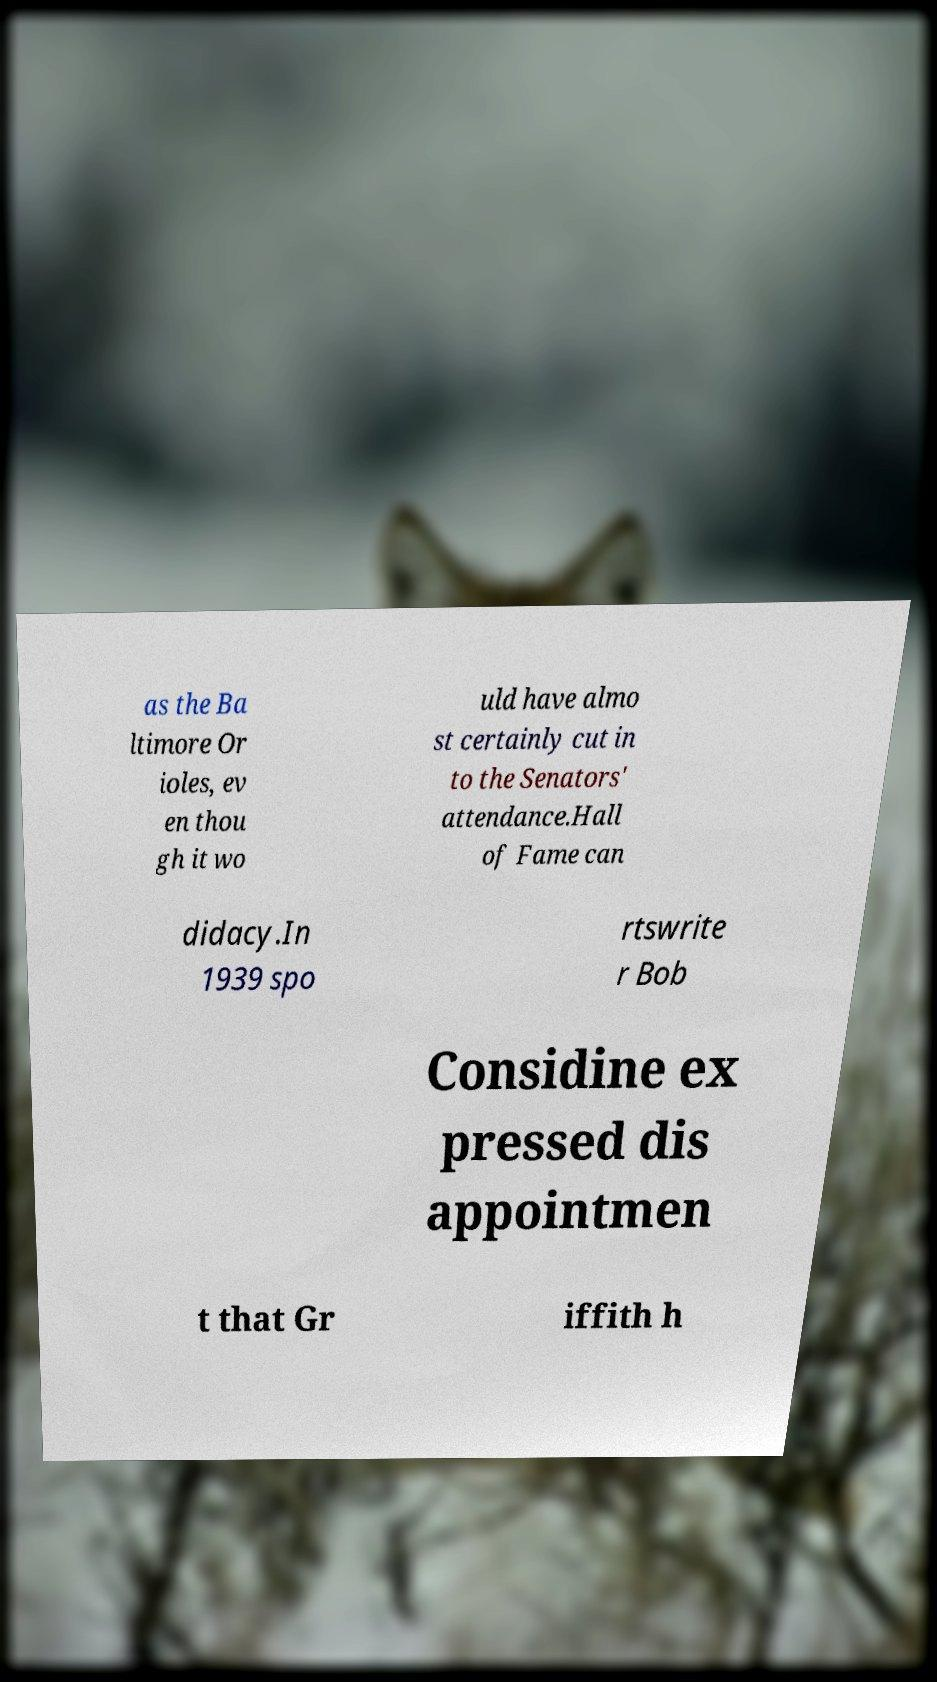I need the written content from this picture converted into text. Can you do that? as the Ba ltimore Or ioles, ev en thou gh it wo uld have almo st certainly cut in to the Senators' attendance.Hall of Fame can didacy.In 1939 spo rtswrite r Bob Considine ex pressed dis appointmen t that Gr iffith h 